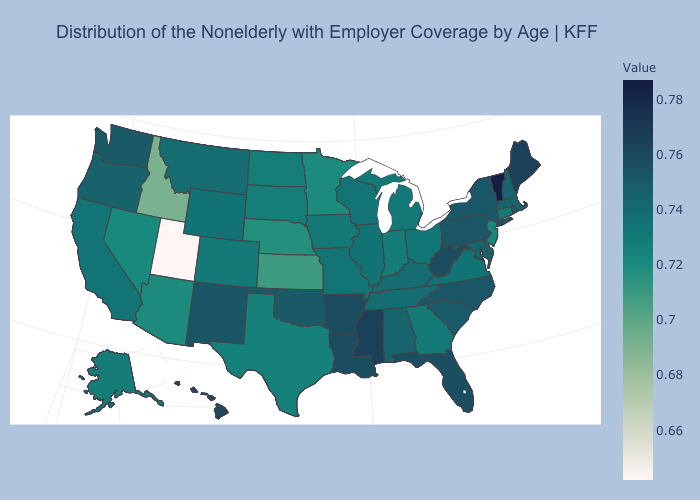Does the map have missing data?
Quick response, please. No. Does Montana have a higher value than Florida?
Write a very short answer. No. Which states have the lowest value in the USA?
Be succinct. Utah. 